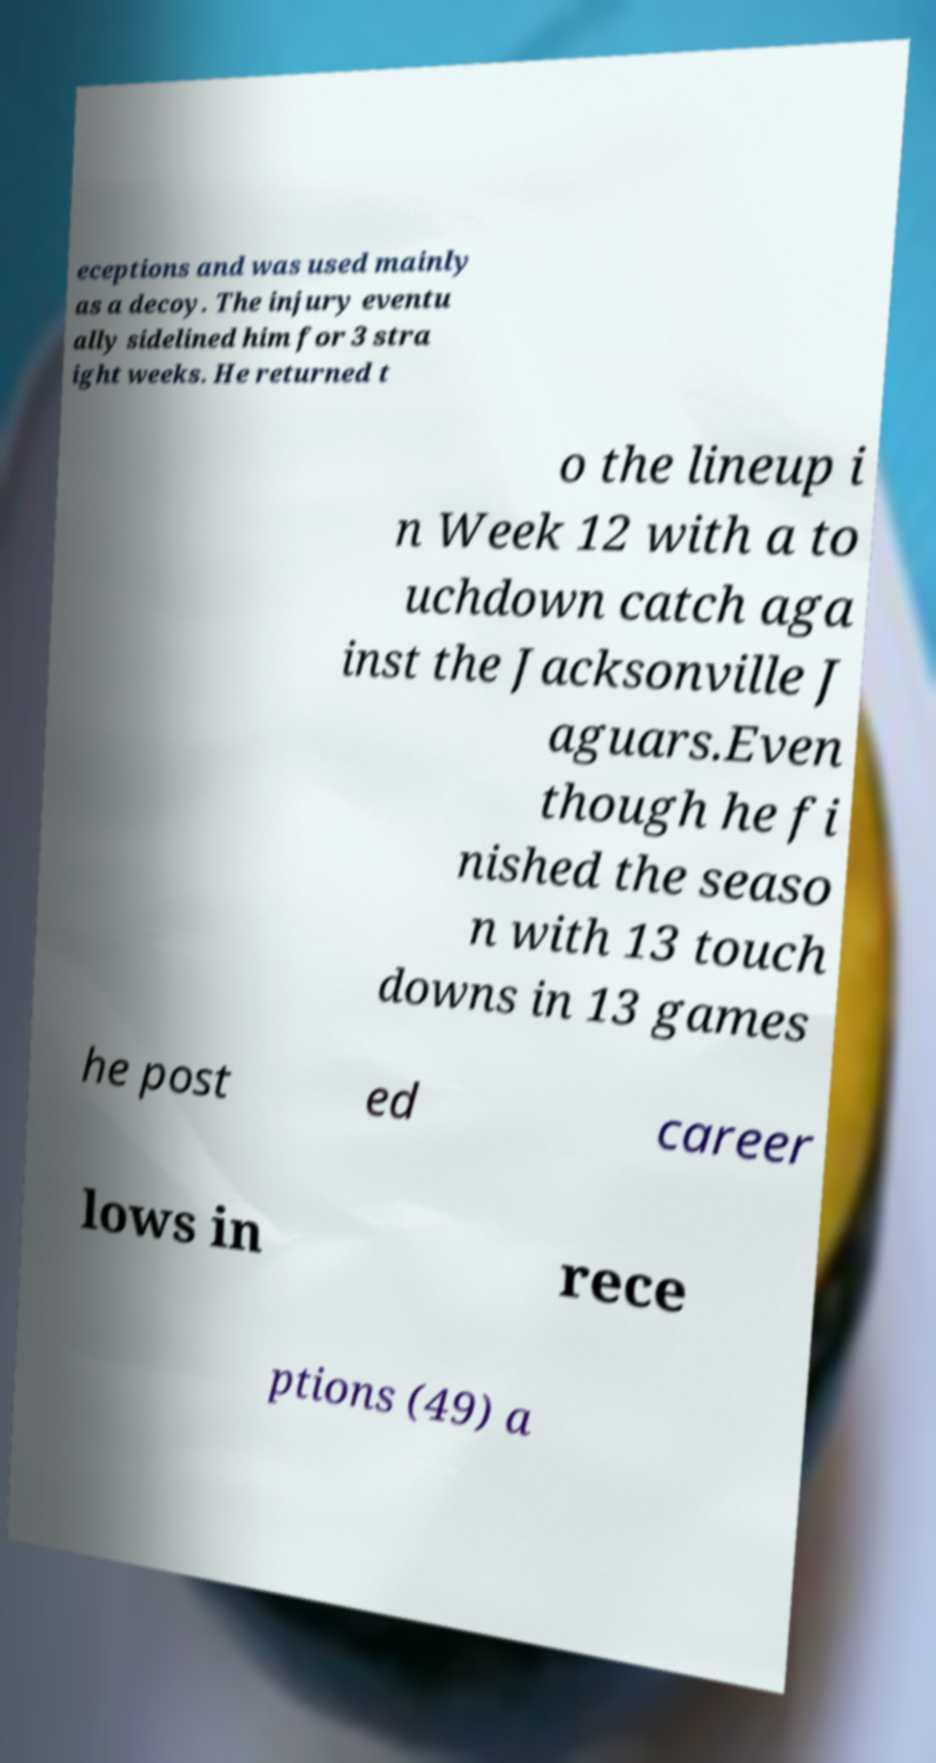Could you extract and type out the text from this image? eceptions and was used mainly as a decoy. The injury eventu ally sidelined him for 3 stra ight weeks. He returned t o the lineup i n Week 12 with a to uchdown catch aga inst the Jacksonville J aguars.Even though he fi nished the seaso n with 13 touch downs in 13 games he post ed career lows in rece ptions (49) a 